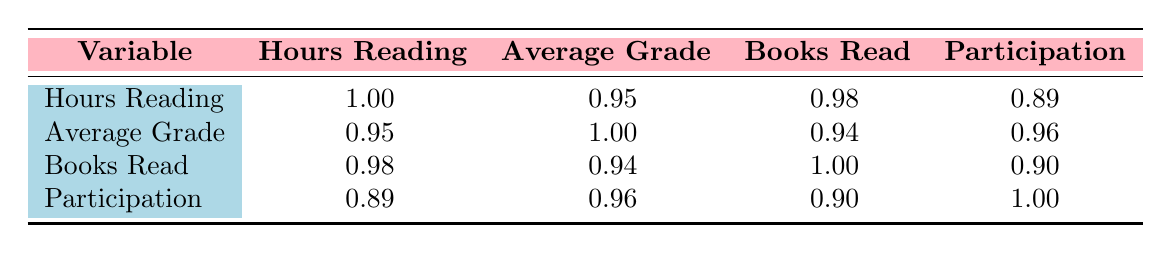What is the correlation between hours reading and average grade? The table shows that the correlation between hours reading and average grade is 0.95. This indicates a strong positive correlation, which means as the hours reading increases, the average grade tends to increase as well.
Answer: 0.95 Is there a correlation between books read and participation? The table lists the correlation between books read and participation as 0.90. A value this high suggests a strong positive correlation, meaning that students who read more tend to participate more in class.
Answer: Yes What is the average correlation between all variables listed in the table? To find the average correlation, sum the values of the correlation coefficients (excluding the diagonal values), which are 0.95, 0.98, 0.89, 0.94, 0.96, 0.90, and divide by 6 (since there are 6 unique correlation pairs). The sum is 0.95 + 0.98 + 0.89 + 0.94 + 0.96 + 0.90 = 5.62. Dividing this by 6 gives an average of 0.935.
Answer: 0.935 What is the correlation between average grade and books read? The table shows that the correlation between average grade and books read is 0.94, indicating a strong positive correlation. This means that an increase in the number of books read is associated with higher average grades.
Answer: 0.94 Is there no correlation between hours reading and participation? The correlation between hours reading and participation is 0.89, which is significantly positive. Therefore, the statement that there is no correlation is false.
Answer: No 